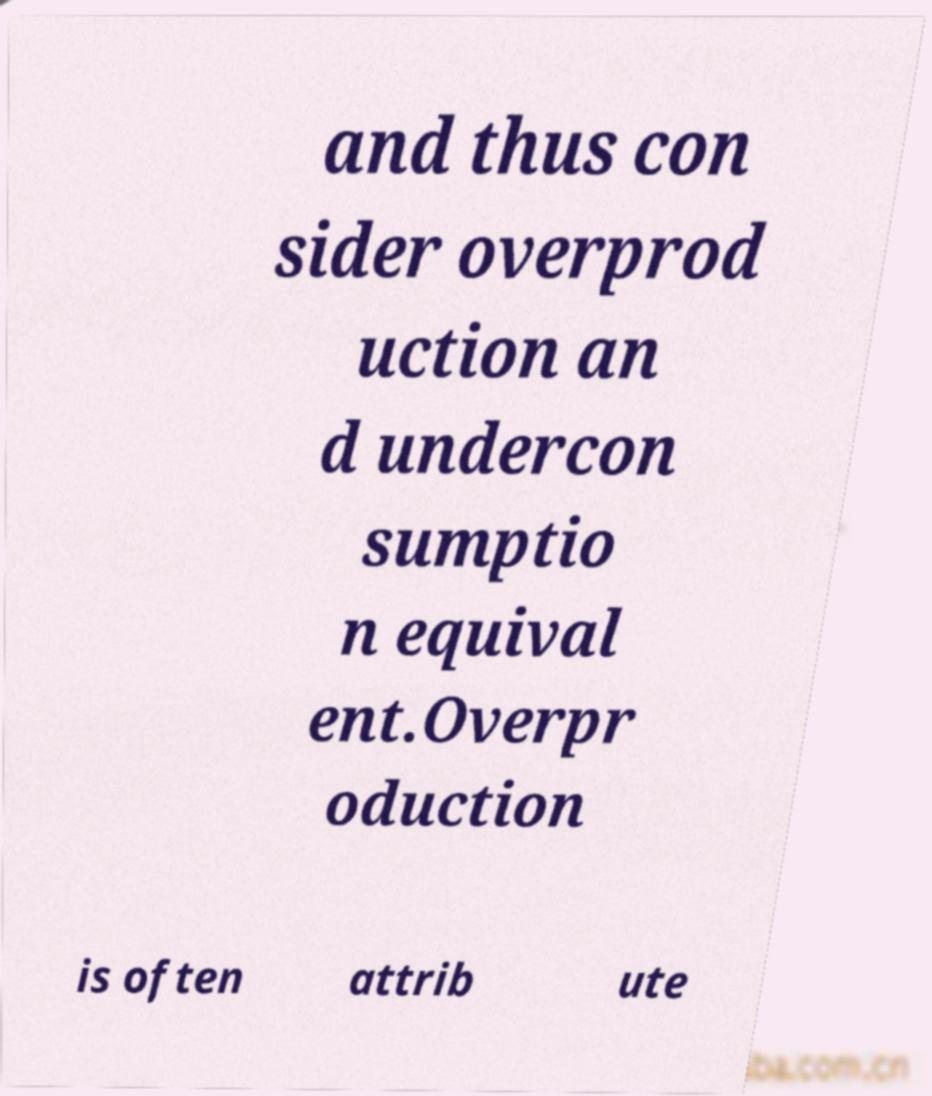I need the written content from this picture converted into text. Can you do that? and thus con sider overprod uction an d undercon sumptio n equival ent.Overpr oduction is often attrib ute 